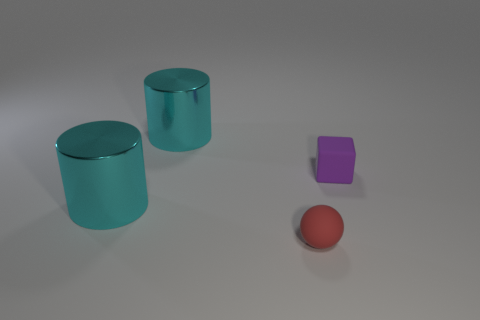Add 1 small purple rubber things. How many objects exist? 5 Subtract all balls. How many objects are left? 3 Subtract all large cyan metal cubes. Subtract all matte spheres. How many objects are left? 3 Add 3 small red matte things. How many small red matte things are left? 4 Add 2 small purple cubes. How many small purple cubes exist? 3 Subtract 0 green cylinders. How many objects are left? 4 Subtract 1 cylinders. How many cylinders are left? 1 Subtract all brown blocks. Subtract all yellow balls. How many blocks are left? 1 